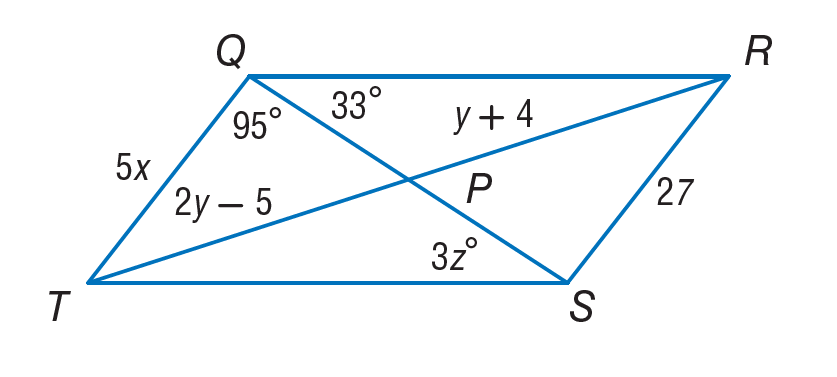Answer the mathemtical geometry problem and directly provide the correct option letter.
Question: If Q R S T is a parallelogram. Find z.
Choices: A: 5.4 B: 7 C: 9 D: 11 D 